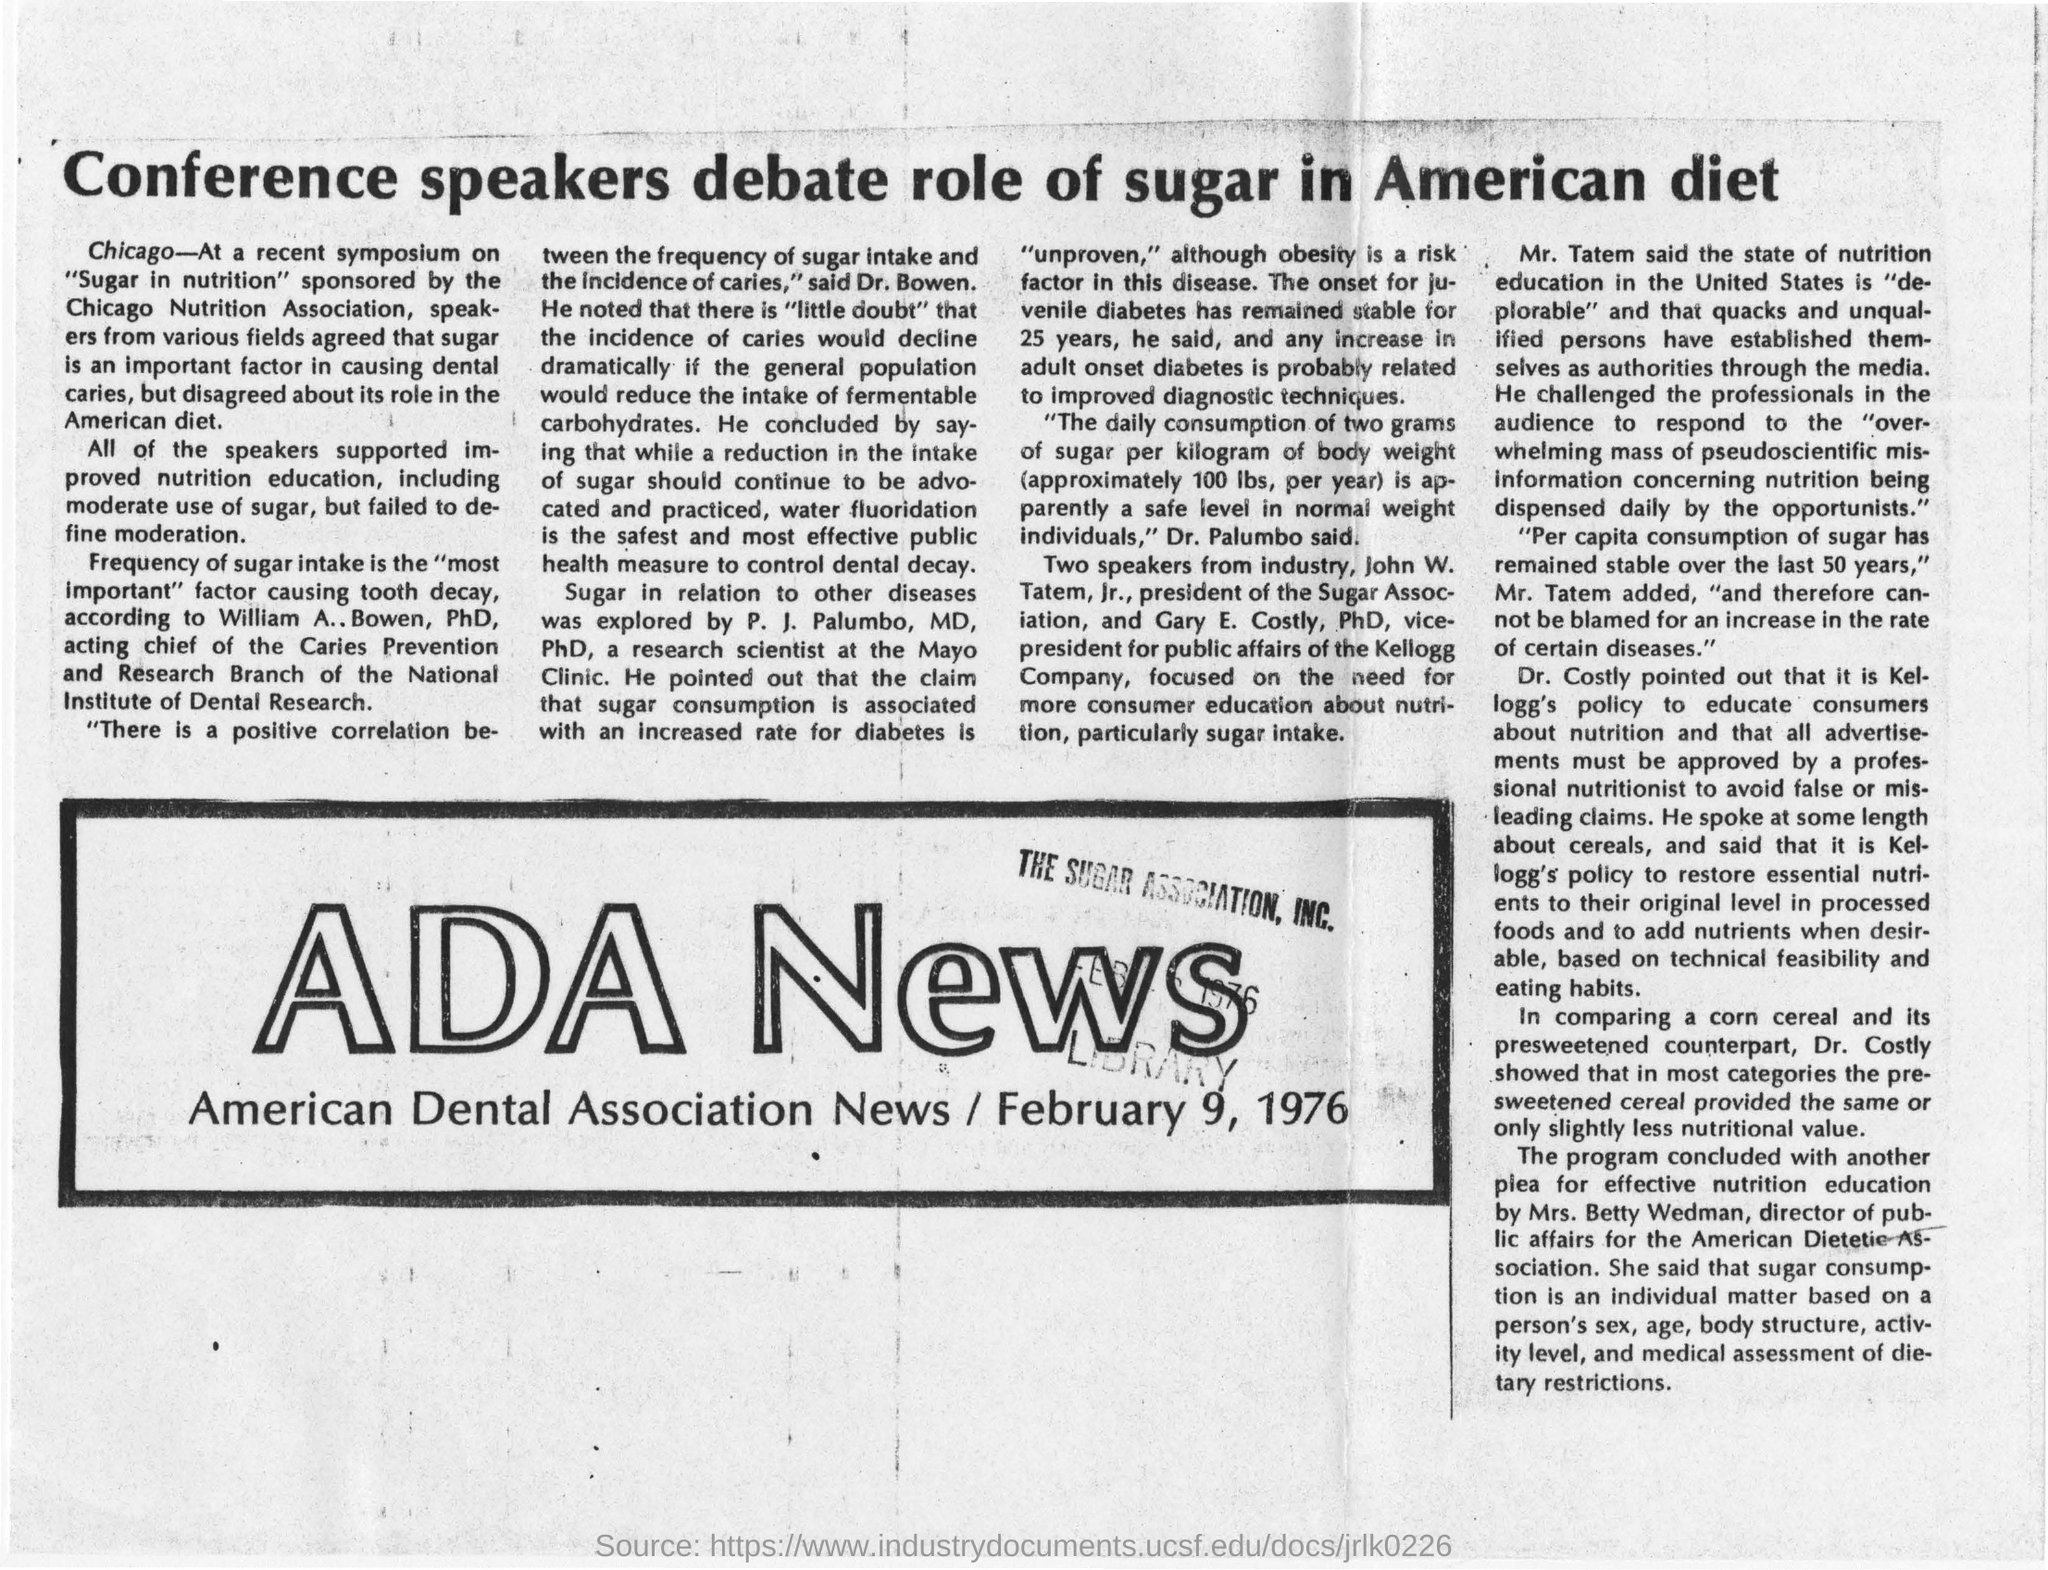Which news is mentioned here?
Keep it short and to the point. ADA News. What is the date mentioned in this document?
Keep it short and to the point. February 9, 1976. Who is the president of the Sugar Association?
Your answer should be compact. John W. Tatem, Jr. What is the designation of Gary  E. Costly?
Offer a very short reply. Vice-president for public affairs of the kellogg company. What is the head line of this news?
Your response must be concise. Conference speakers debate role of sugar in American diet. Which scientist explored sugar in relation to other diseases?
Keep it short and to the point. P. J. Palumbo, MD, PhD. Which association sponsored the symposium on "Sugar in nutrition" ?
Your answer should be compact. Chicago Nutrition Association. Who is the director of public affairs for the American Dietetic Association?
Ensure brevity in your answer.  Mrs. Betty Wedman. 